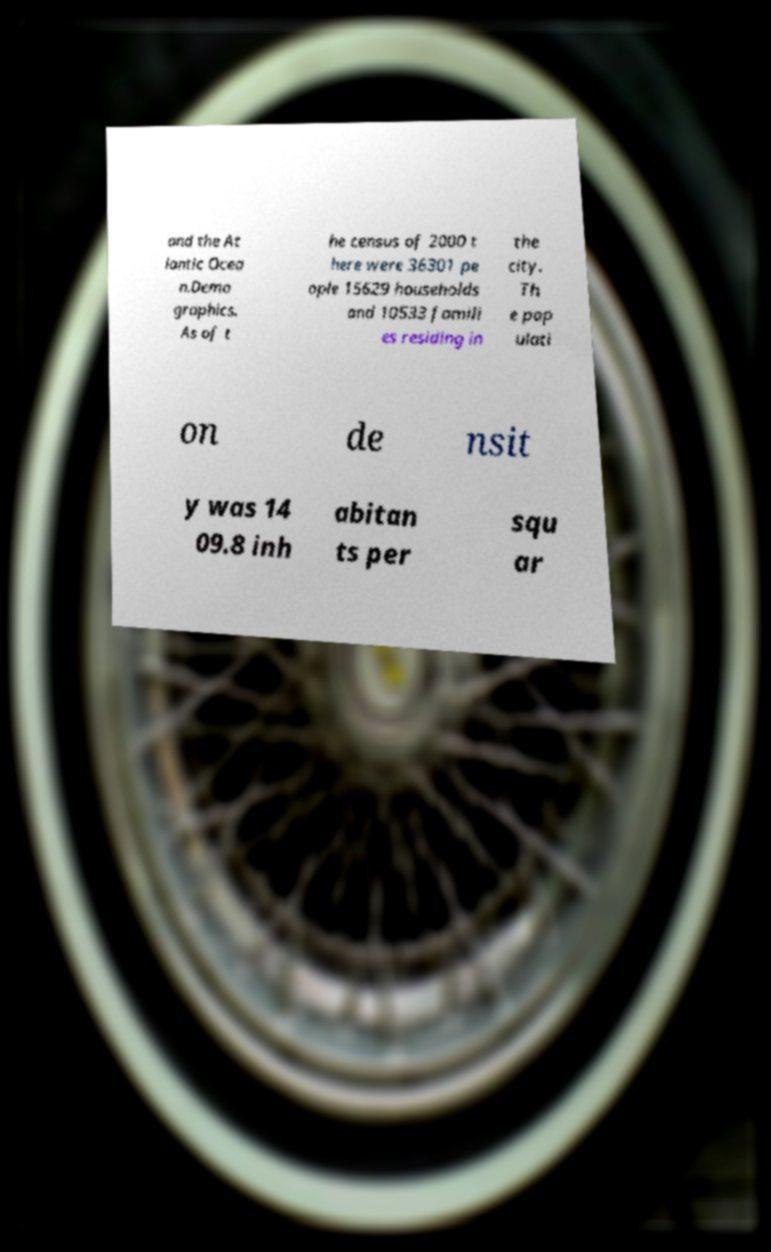Please read and relay the text visible in this image. What does it say? and the At lantic Ocea n.Demo graphics. As of t he census of 2000 t here were 36301 pe ople 15629 households and 10533 famili es residing in the city. Th e pop ulati on de nsit y was 14 09.8 inh abitan ts per squ ar 